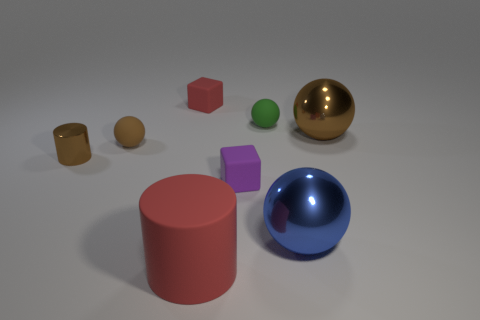Add 1 small metallic things. How many objects exist? 9 Subtract all red blocks. How many blocks are left? 1 Subtract all blue spheres. How many spheres are left? 3 Subtract 1 cylinders. How many cylinders are left? 1 Subtract all cylinders. How many objects are left? 6 Subtract all green cylinders. Subtract all purple cubes. How many cylinders are left? 2 Subtract all red spheres. How many gray blocks are left? 0 Add 4 purple shiny balls. How many purple shiny balls exist? 4 Subtract 0 cyan balls. How many objects are left? 8 Subtract all red matte things. Subtract all big brown metal spheres. How many objects are left? 5 